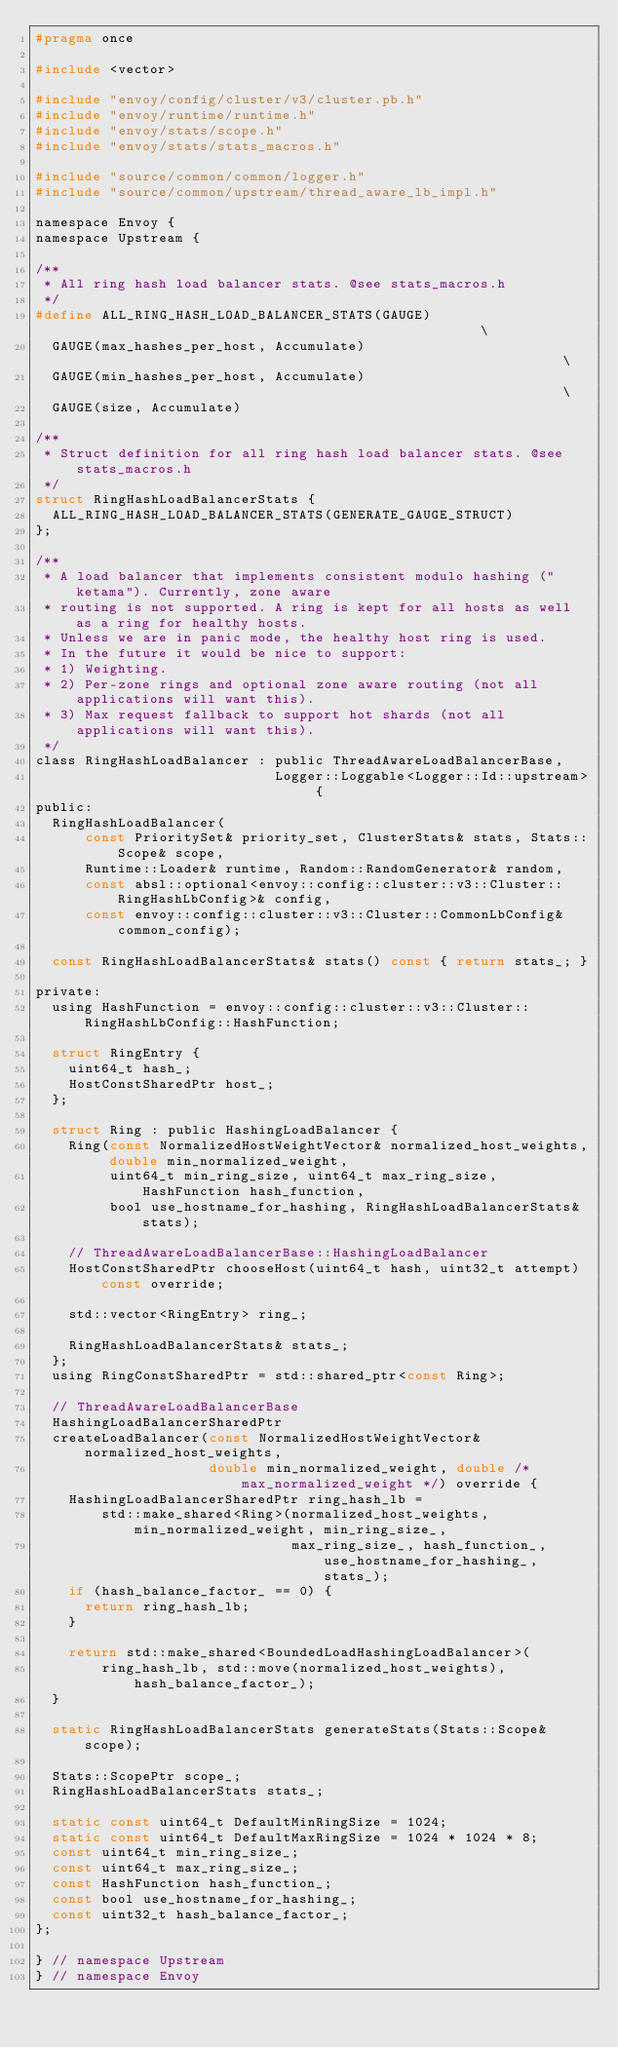Convert code to text. <code><loc_0><loc_0><loc_500><loc_500><_C_>#pragma once

#include <vector>

#include "envoy/config/cluster/v3/cluster.pb.h"
#include "envoy/runtime/runtime.h"
#include "envoy/stats/scope.h"
#include "envoy/stats/stats_macros.h"

#include "source/common/common/logger.h"
#include "source/common/upstream/thread_aware_lb_impl.h"

namespace Envoy {
namespace Upstream {

/**
 * All ring hash load balancer stats. @see stats_macros.h
 */
#define ALL_RING_HASH_LOAD_BALANCER_STATS(GAUGE)                                                   \
  GAUGE(max_hashes_per_host, Accumulate)                                                           \
  GAUGE(min_hashes_per_host, Accumulate)                                                           \
  GAUGE(size, Accumulate)

/**
 * Struct definition for all ring hash load balancer stats. @see stats_macros.h
 */
struct RingHashLoadBalancerStats {
  ALL_RING_HASH_LOAD_BALANCER_STATS(GENERATE_GAUGE_STRUCT)
};

/**
 * A load balancer that implements consistent modulo hashing ("ketama"). Currently, zone aware
 * routing is not supported. A ring is kept for all hosts as well as a ring for healthy hosts.
 * Unless we are in panic mode, the healthy host ring is used.
 * In the future it would be nice to support:
 * 1) Weighting.
 * 2) Per-zone rings and optional zone aware routing (not all applications will want this).
 * 3) Max request fallback to support hot shards (not all applications will want this).
 */
class RingHashLoadBalancer : public ThreadAwareLoadBalancerBase,
                             Logger::Loggable<Logger::Id::upstream> {
public:
  RingHashLoadBalancer(
      const PrioritySet& priority_set, ClusterStats& stats, Stats::Scope& scope,
      Runtime::Loader& runtime, Random::RandomGenerator& random,
      const absl::optional<envoy::config::cluster::v3::Cluster::RingHashLbConfig>& config,
      const envoy::config::cluster::v3::Cluster::CommonLbConfig& common_config);

  const RingHashLoadBalancerStats& stats() const { return stats_; }

private:
  using HashFunction = envoy::config::cluster::v3::Cluster::RingHashLbConfig::HashFunction;

  struct RingEntry {
    uint64_t hash_;
    HostConstSharedPtr host_;
  };

  struct Ring : public HashingLoadBalancer {
    Ring(const NormalizedHostWeightVector& normalized_host_weights, double min_normalized_weight,
         uint64_t min_ring_size, uint64_t max_ring_size, HashFunction hash_function,
         bool use_hostname_for_hashing, RingHashLoadBalancerStats& stats);

    // ThreadAwareLoadBalancerBase::HashingLoadBalancer
    HostConstSharedPtr chooseHost(uint64_t hash, uint32_t attempt) const override;

    std::vector<RingEntry> ring_;

    RingHashLoadBalancerStats& stats_;
  };
  using RingConstSharedPtr = std::shared_ptr<const Ring>;

  // ThreadAwareLoadBalancerBase
  HashingLoadBalancerSharedPtr
  createLoadBalancer(const NormalizedHostWeightVector& normalized_host_weights,
                     double min_normalized_weight, double /* max_normalized_weight */) override {
    HashingLoadBalancerSharedPtr ring_hash_lb =
        std::make_shared<Ring>(normalized_host_weights, min_normalized_weight, min_ring_size_,
                               max_ring_size_, hash_function_, use_hostname_for_hashing_, stats_);
    if (hash_balance_factor_ == 0) {
      return ring_hash_lb;
    }

    return std::make_shared<BoundedLoadHashingLoadBalancer>(
        ring_hash_lb, std::move(normalized_host_weights), hash_balance_factor_);
  }

  static RingHashLoadBalancerStats generateStats(Stats::Scope& scope);

  Stats::ScopePtr scope_;
  RingHashLoadBalancerStats stats_;

  static const uint64_t DefaultMinRingSize = 1024;
  static const uint64_t DefaultMaxRingSize = 1024 * 1024 * 8;
  const uint64_t min_ring_size_;
  const uint64_t max_ring_size_;
  const HashFunction hash_function_;
  const bool use_hostname_for_hashing_;
  const uint32_t hash_balance_factor_;
};

} // namespace Upstream
} // namespace Envoy
</code> 